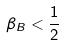Convert formula to latex. <formula><loc_0><loc_0><loc_500><loc_500>\beta _ { B } < \frac { 1 } { 2 }</formula> 